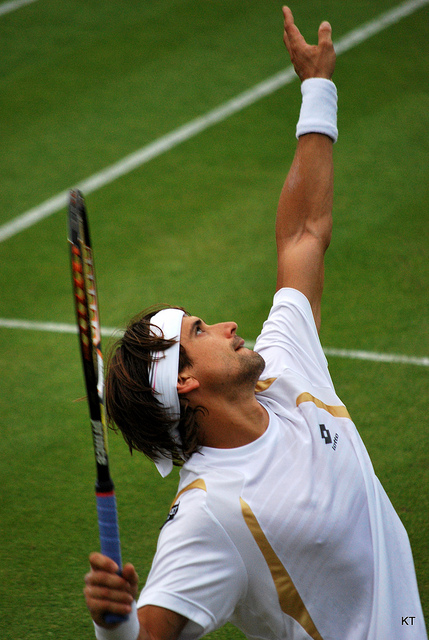<image>What is the players name? I don't know the player's name. It could be 'randy', 'kt', 'rafael', 'agassi', 'federer', or 'andre agassi'. What is the players name? I don't know what the player's name is. It can be Randy, KT, Rafael, Agassi, Federer, or Andre Agassi. 